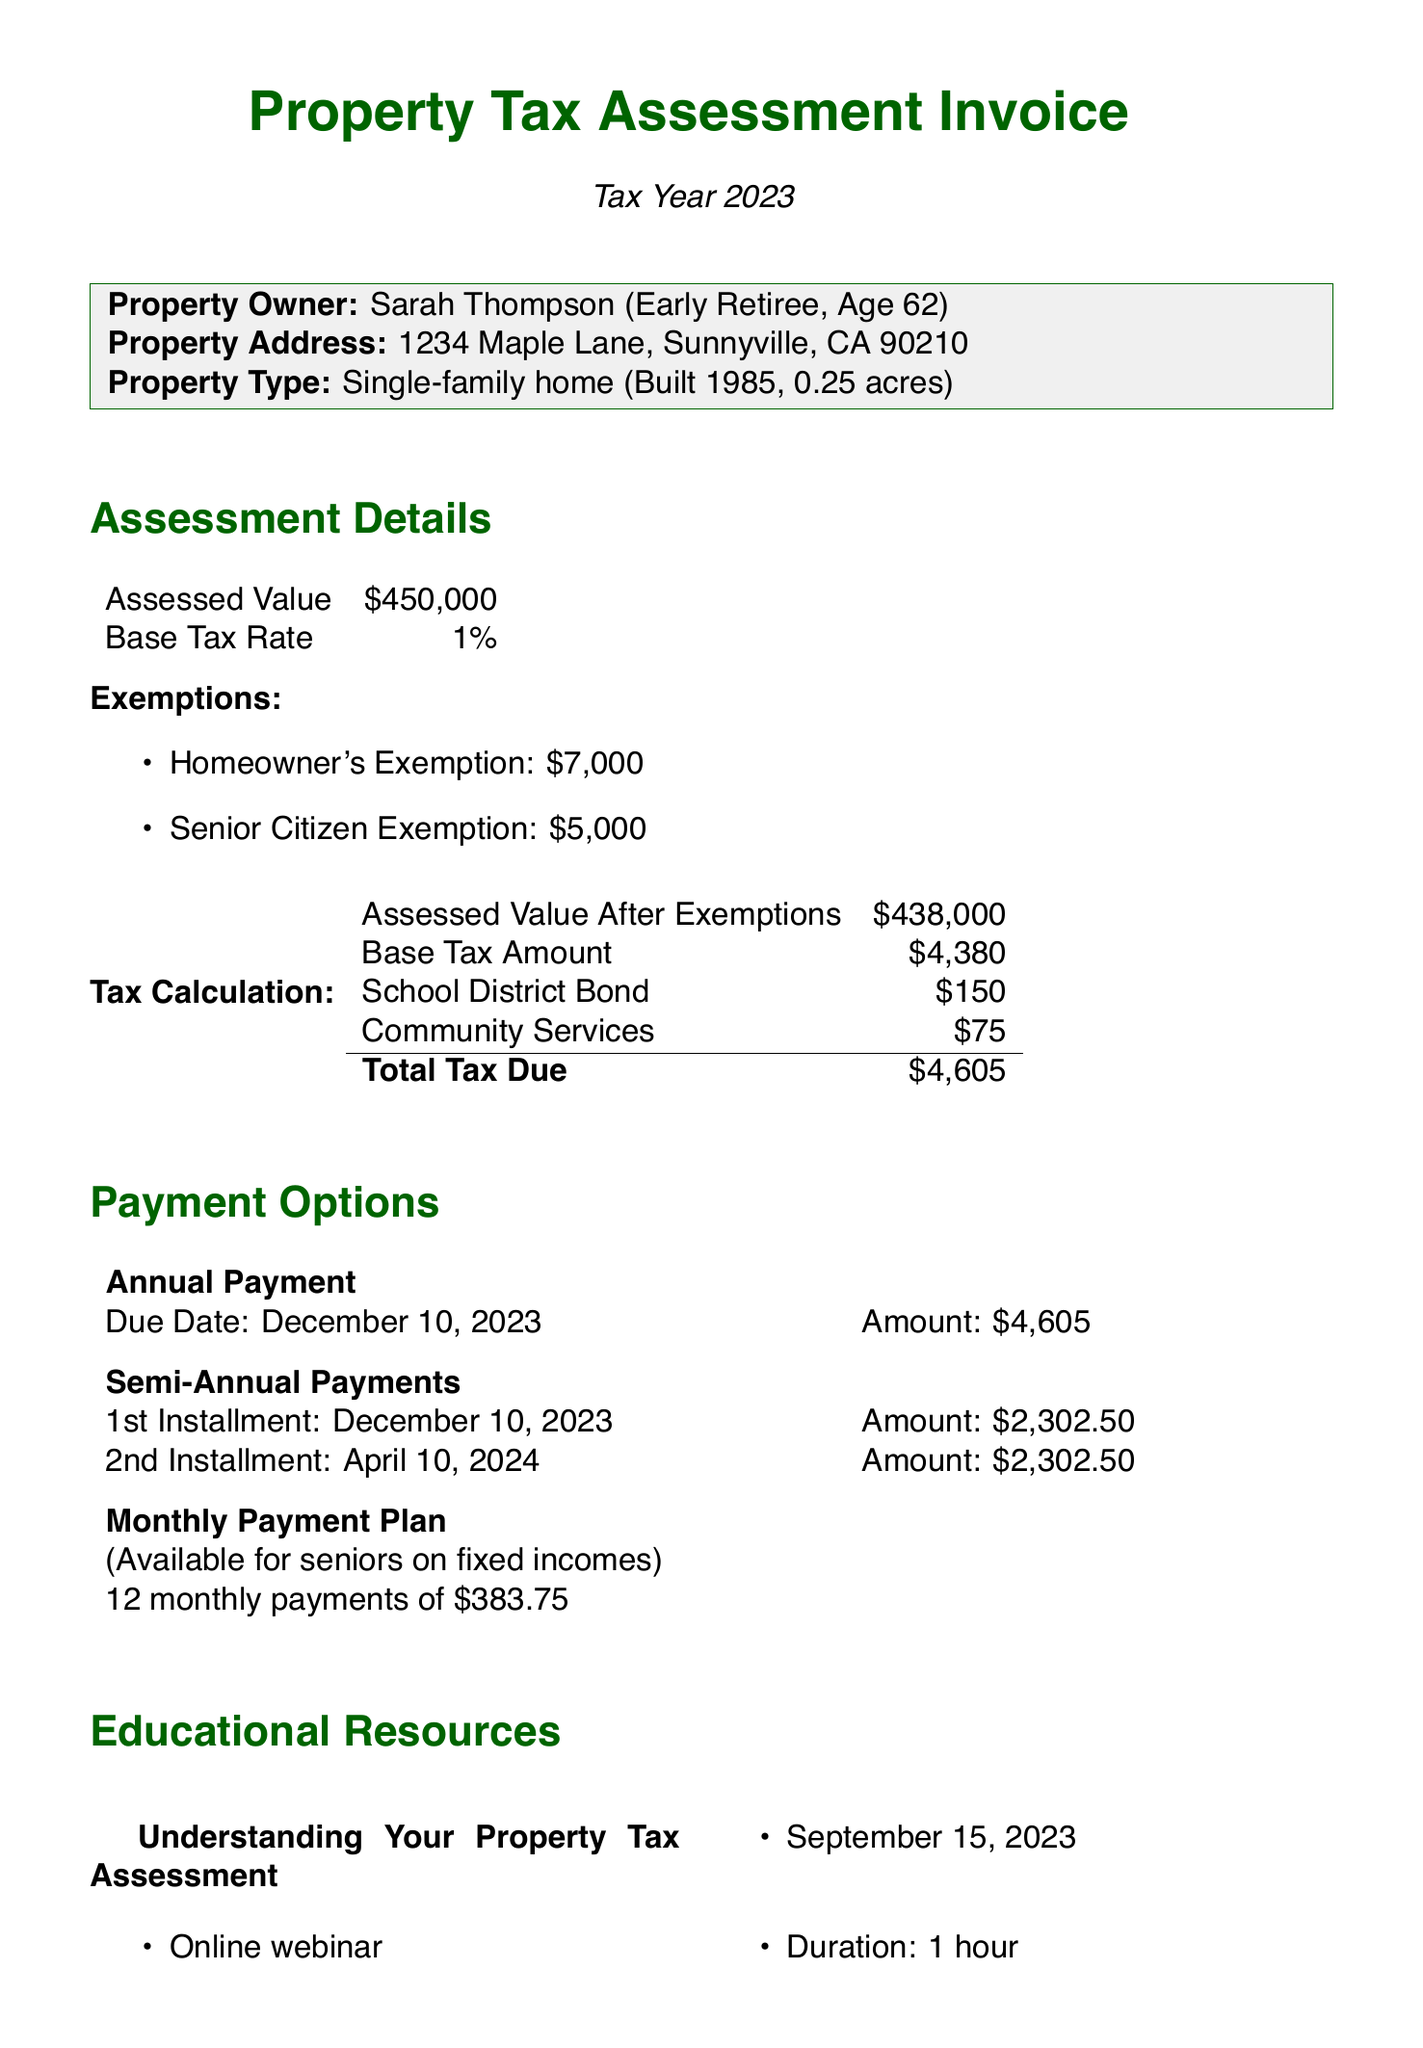What is the assessed value? The assessed value listed in the document is $450,000.
Answer: $450,000 How much is the Senior Citizen Exemption? The document states that the Senior Citizen Exemption amount is $5,000.
Answer: $5,000 What is the total tax due? The total tax due is calculated as $4,605 according to the tax calculation section.
Answer: $4,605 When is the due date for the annual payment? The due date for the annual payment is specified as December 10, 2023.
Answer: December 10, 2023 What is the monthly payment amount under the Monthly Payment Plan? The Monthly Payment Plan states the monthly amount is $383.75 for seniors on fixed incomes.
Answer: $383.75 What type of educational resource is available on September 15, 2023? The resource available on that date is an online webinar titled "Understanding Your Property Tax Assessment."
Answer: Online webinar How many total exemptions does Sarah receive? There are two exemptions listed for Sarah: Homeowner's Exemption and Senior Citizen Exemption.
Answer: Two What is the name of the department listed for contact? The name of the department for contact is Sunnyville County Assessor's Office.
Answer: Sunnyville County Assessor's Office 